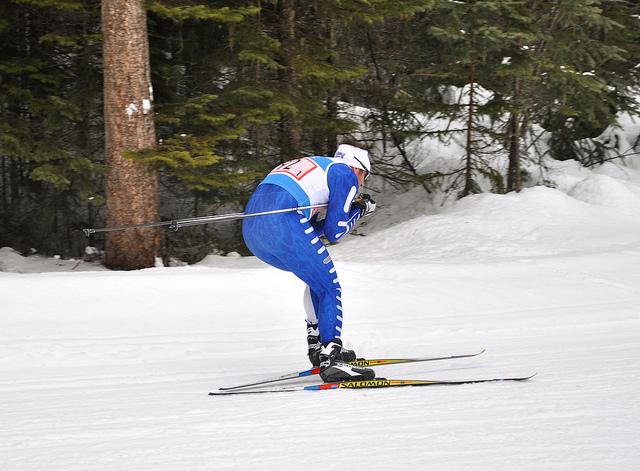Is he in a race?
Give a very brief answer. Yes. Where is the skiing?
Concise answer only. Slope. Why does the skier have numbers on their shirt?
Write a very short answer. Racing. Are there shadows in the scene?
Keep it brief. No. Is it snowing?
Give a very brief answer. No. 